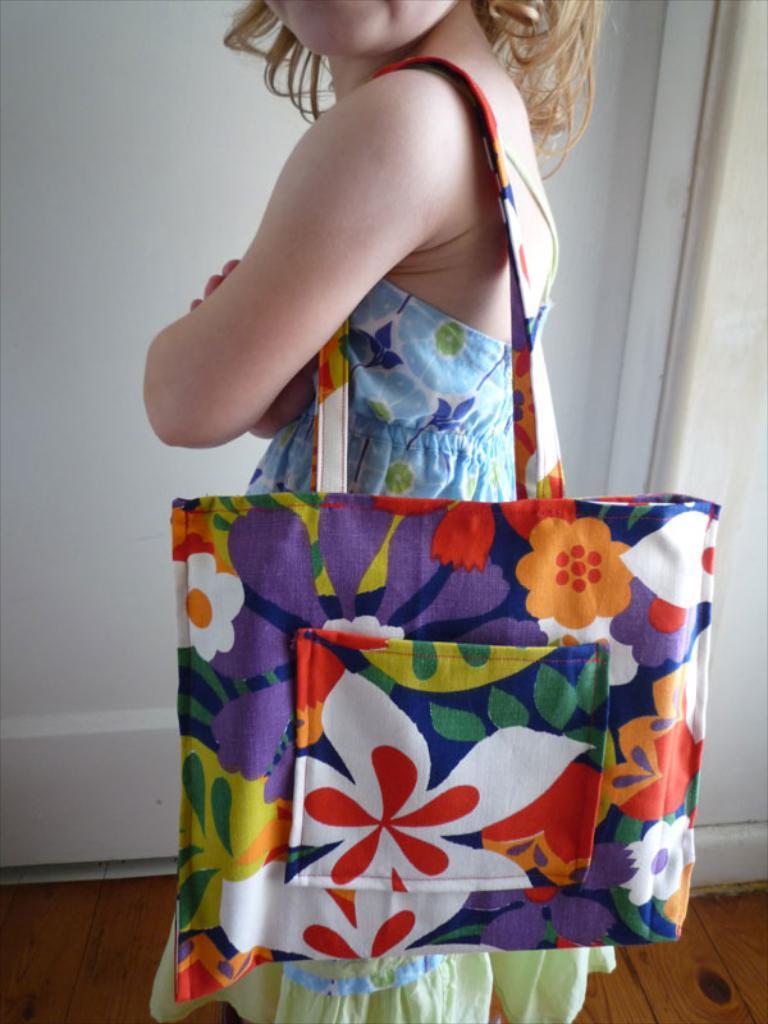Please provide a concise description of this image. In the image a person is standing and holding a bag. Behind the person there is a wall. 